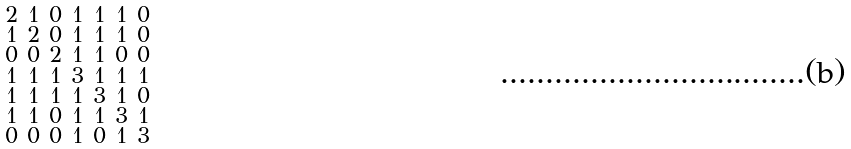Convert formula to latex. <formula><loc_0><loc_0><loc_500><loc_500>\begin{smallmatrix} 2 & 1 & 0 & 1 & 1 & 1 & 0 \\ 1 & 2 & 0 & 1 & 1 & 1 & 0 \\ 0 & 0 & 2 & 1 & 1 & 0 & 0 \\ 1 & 1 & 1 & 3 & 1 & 1 & 1 \\ 1 & 1 & 1 & 1 & 3 & 1 & 0 \\ 1 & 1 & 0 & 1 & 1 & 3 & 1 \\ 0 & 0 & 0 & 1 & 0 & 1 & 3 \end{smallmatrix}</formula> 